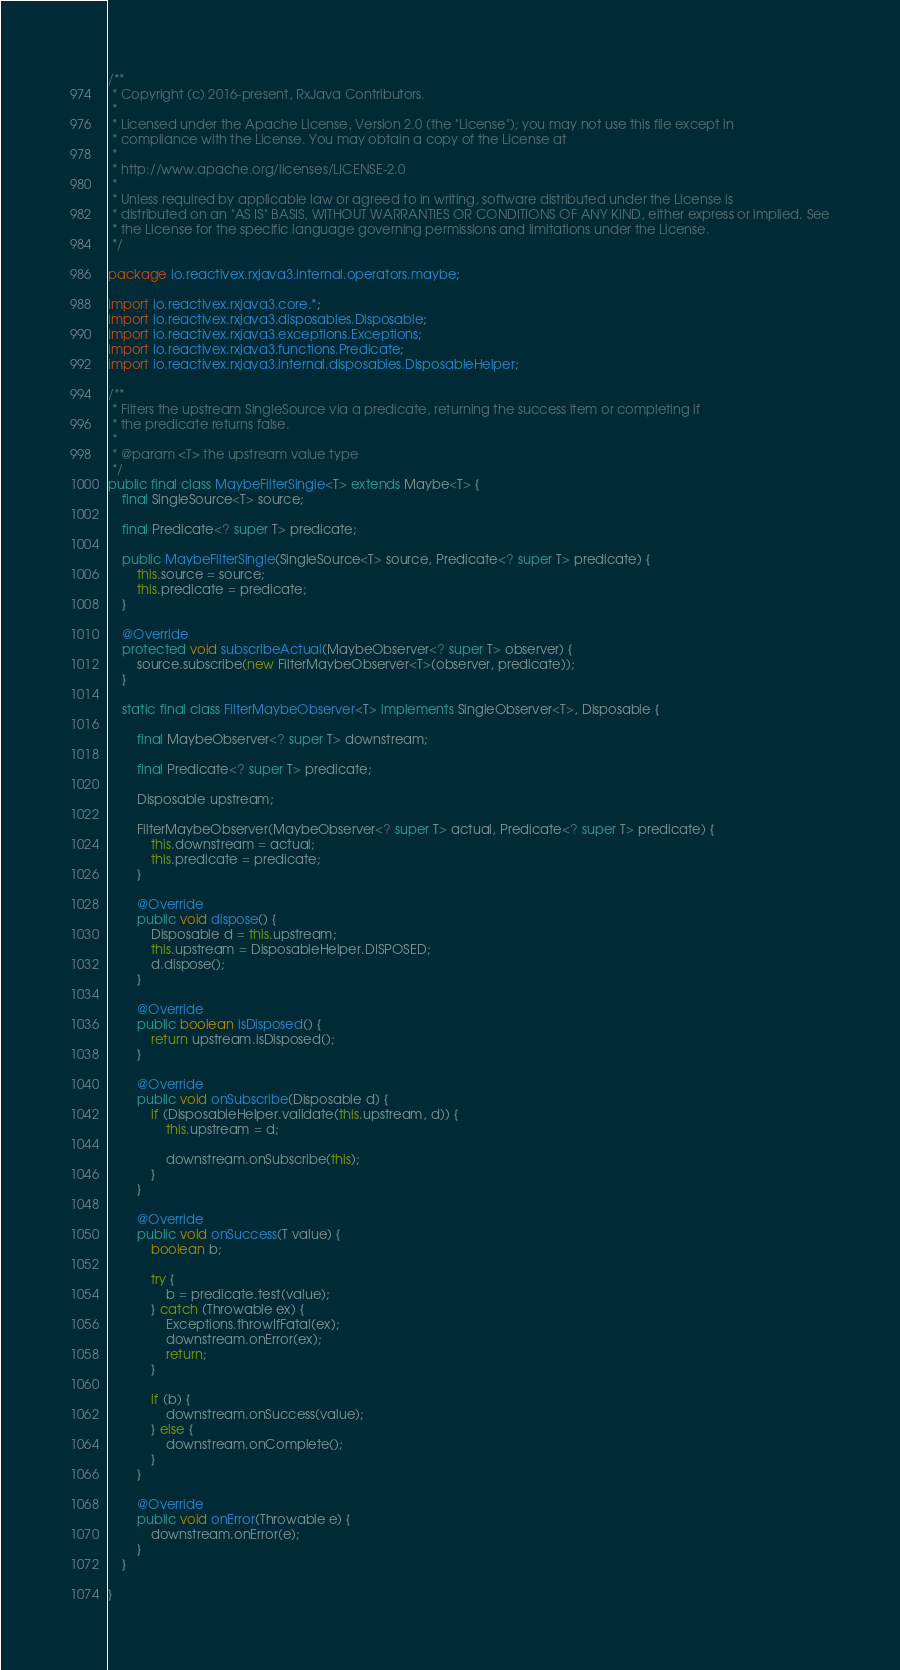Convert code to text. <code><loc_0><loc_0><loc_500><loc_500><_Java_>/**
 * Copyright (c) 2016-present, RxJava Contributors.
 *
 * Licensed under the Apache License, Version 2.0 (the "License"); you may not use this file except in
 * compliance with the License. You may obtain a copy of the License at
 *
 * http://www.apache.org/licenses/LICENSE-2.0
 *
 * Unless required by applicable law or agreed to in writing, software distributed under the License is
 * distributed on an "AS IS" BASIS, WITHOUT WARRANTIES OR CONDITIONS OF ANY KIND, either express or implied. See
 * the License for the specific language governing permissions and limitations under the License.
 */

package io.reactivex.rxjava3.internal.operators.maybe;

import io.reactivex.rxjava3.core.*;
import io.reactivex.rxjava3.disposables.Disposable;
import io.reactivex.rxjava3.exceptions.Exceptions;
import io.reactivex.rxjava3.functions.Predicate;
import io.reactivex.rxjava3.internal.disposables.DisposableHelper;

/**
 * Filters the upstream SingleSource via a predicate, returning the success item or completing if
 * the predicate returns false.
 *
 * @param <T> the upstream value type
 */
public final class MaybeFilterSingle<T> extends Maybe<T> {
    final SingleSource<T> source;

    final Predicate<? super T> predicate;

    public MaybeFilterSingle(SingleSource<T> source, Predicate<? super T> predicate) {
        this.source = source;
        this.predicate = predicate;
    }

    @Override
    protected void subscribeActual(MaybeObserver<? super T> observer) {
        source.subscribe(new FilterMaybeObserver<T>(observer, predicate));
    }

    static final class FilterMaybeObserver<T> implements SingleObserver<T>, Disposable {

        final MaybeObserver<? super T> downstream;

        final Predicate<? super T> predicate;

        Disposable upstream;

        FilterMaybeObserver(MaybeObserver<? super T> actual, Predicate<? super T> predicate) {
            this.downstream = actual;
            this.predicate = predicate;
        }

        @Override
        public void dispose() {
            Disposable d = this.upstream;
            this.upstream = DisposableHelper.DISPOSED;
            d.dispose();
        }

        @Override
        public boolean isDisposed() {
            return upstream.isDisposed();
        }

        @Override
        public void onSubscribe(Disposable d) {
            if (DisposableHelper.validate(this.upstream, d)) {
                this.upstream = d;

                downstream.onSubscribe(this);
            }
        }

        @Override
        public void onSuccess(T value) {
            boolean b;

            try {
                b = predicate.test(value);
            } catch (Throwable ex) {
                Exceptions.throwIfFatal(ex);
                downstream.onError(ex);
                return;
            }

            if (b) {
                downstream.onSuccess(value);
            } else {
                downstream.onComplete();
            }
        }

        @Override
        public void onError(Throwable e) {
            downstream.onError(e);
        }
    }

}
</code> 